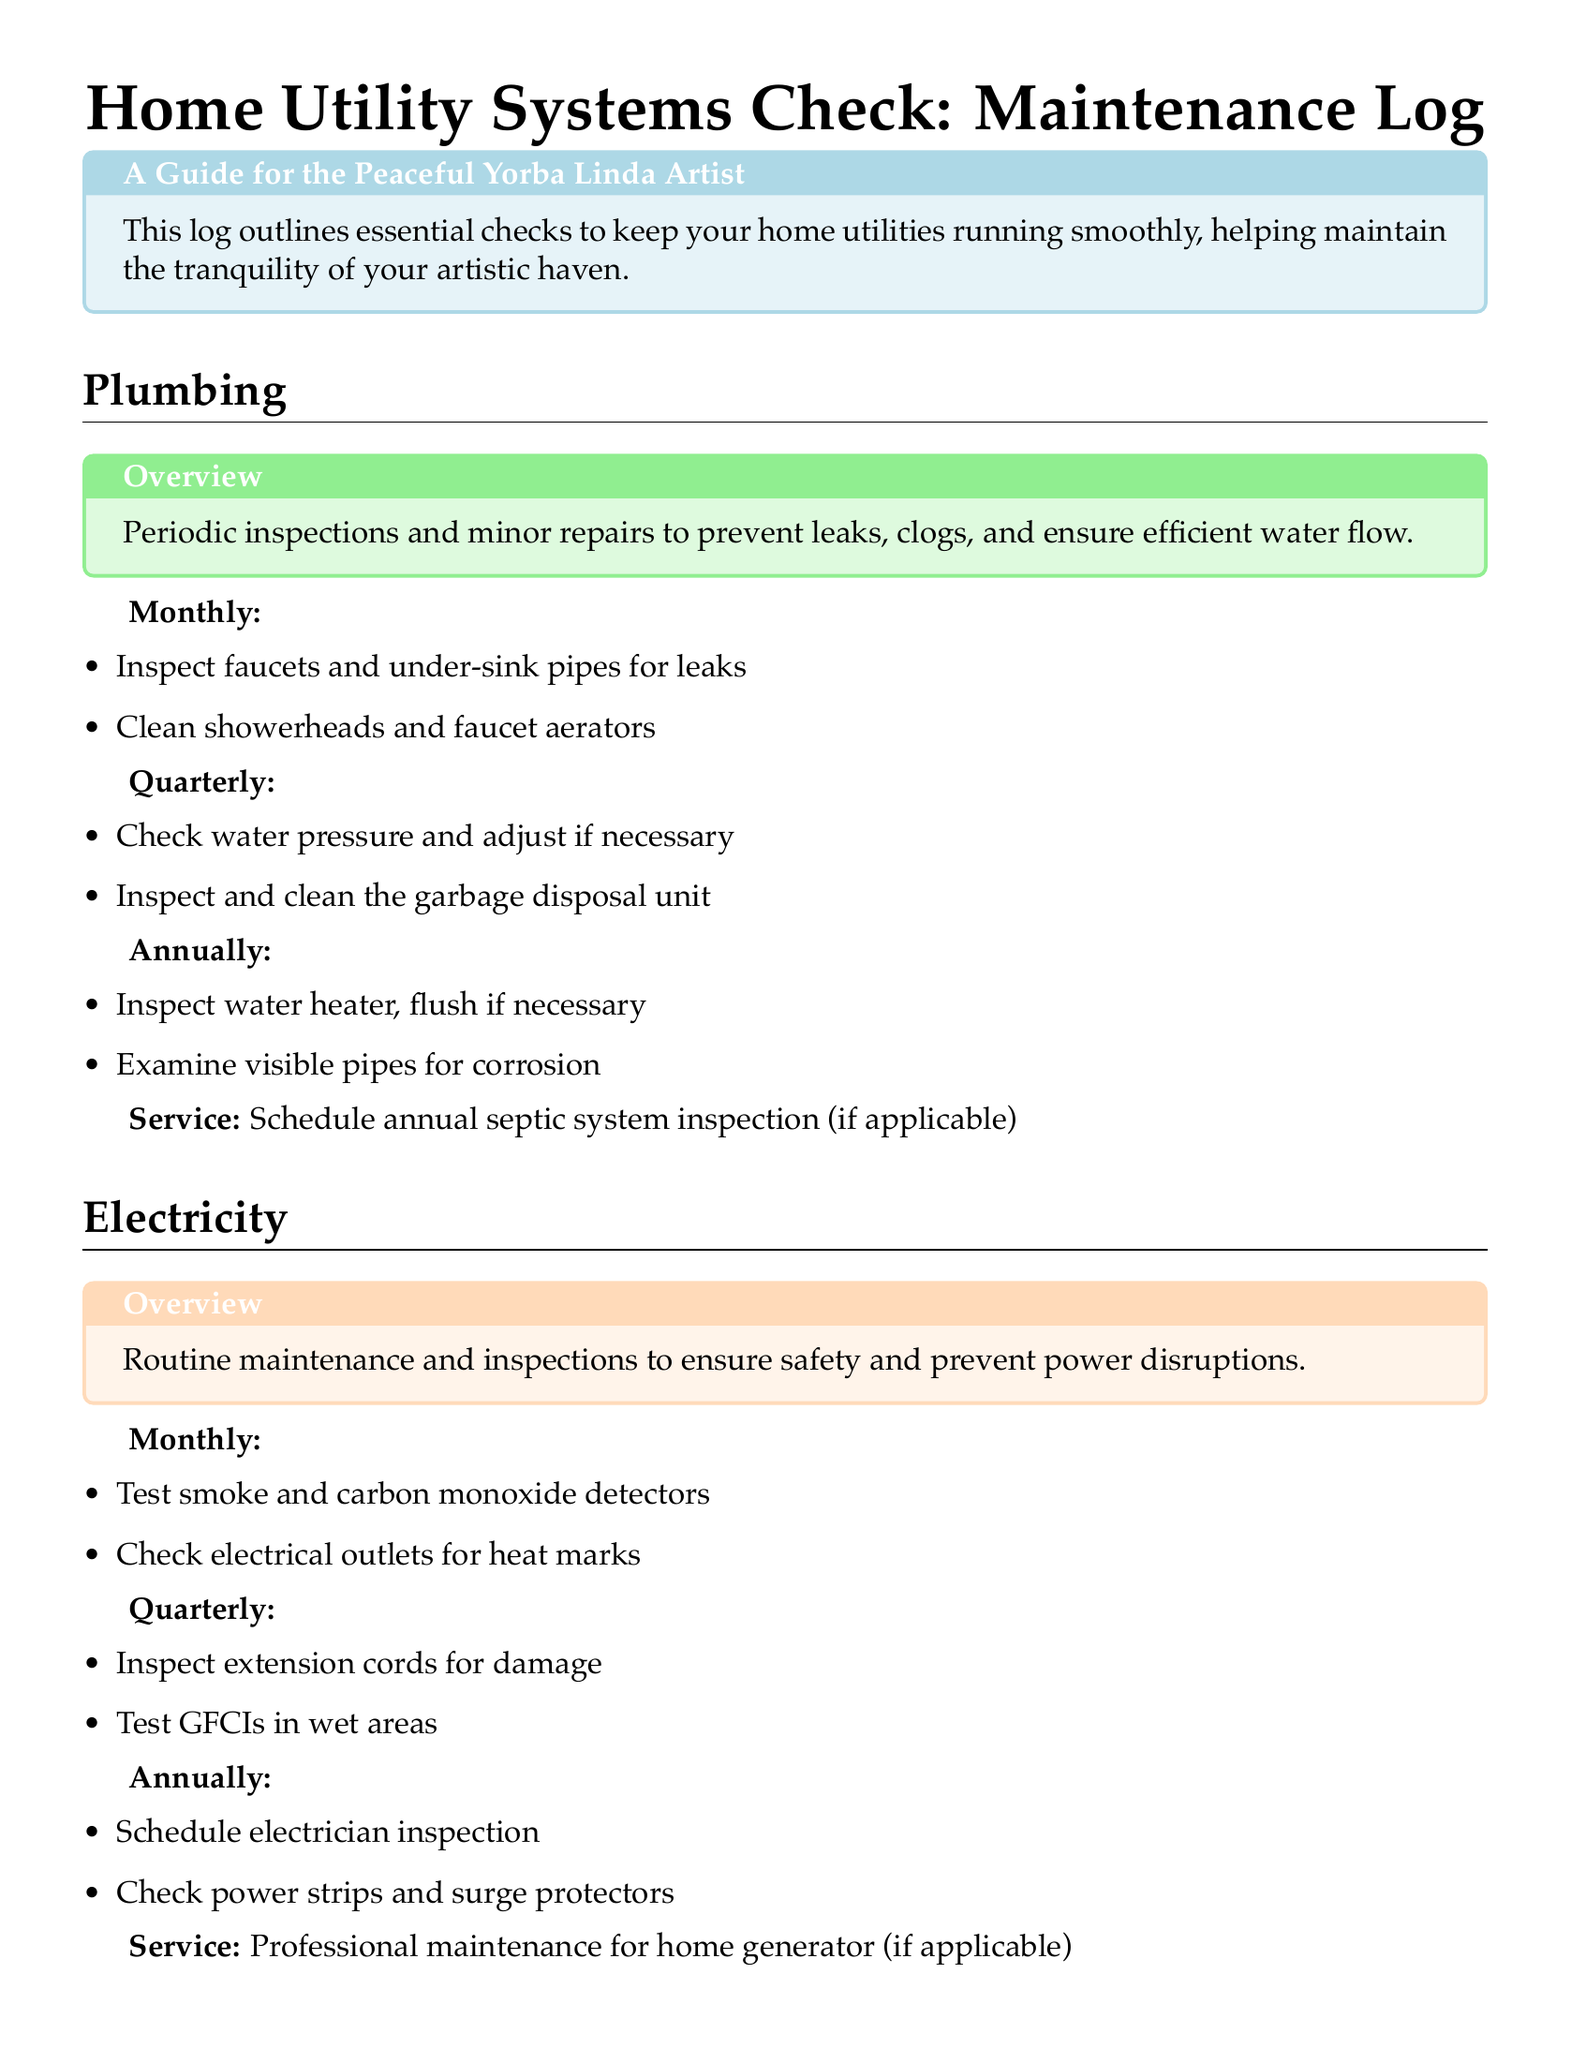what is the main purpose of the log? The log outlines essential checks to keep home utilities running smoothly, helping maintain tranquility.
Answer: essential checks for home utilities how often should HVAC filters be replaced? The document states that HVAC filters should be replaced or cleaned monthly.
Answer: monthly what kind of system inspection is scheduled annually for plumbing? The annual inspection for plumbing involves inspecting the water heater and flushing if necessary.
Answer: water heater inspection how many times should electrical outlets be checked for heat marks? According to the document, electrical outlets should be checked for heat marks monthly.
Answer: monthly what is a recommended quarterly check for heating and cooling systems? A recommended quarterly check involves inspecting condensation drain for blockage.
Answer: inspect condensation drain what is the monthly task for inspecting faucets? The monthly task includes inspecting faucets for leaks.
Answer: inspecting faucets for leaks which utility system requires testing smoke detectors monthly? The electricity utility system requires testing smoke detectors monthly.
Answer: electricity what service is required for home generators? The document specifies professional maintenance for home generators if applicable.
Answer: professional maintenance how often should the garbage disposal unit be cleaned? The garbage disposal unit should be inspected and cleaned quarterly.
Answer: quarterly 